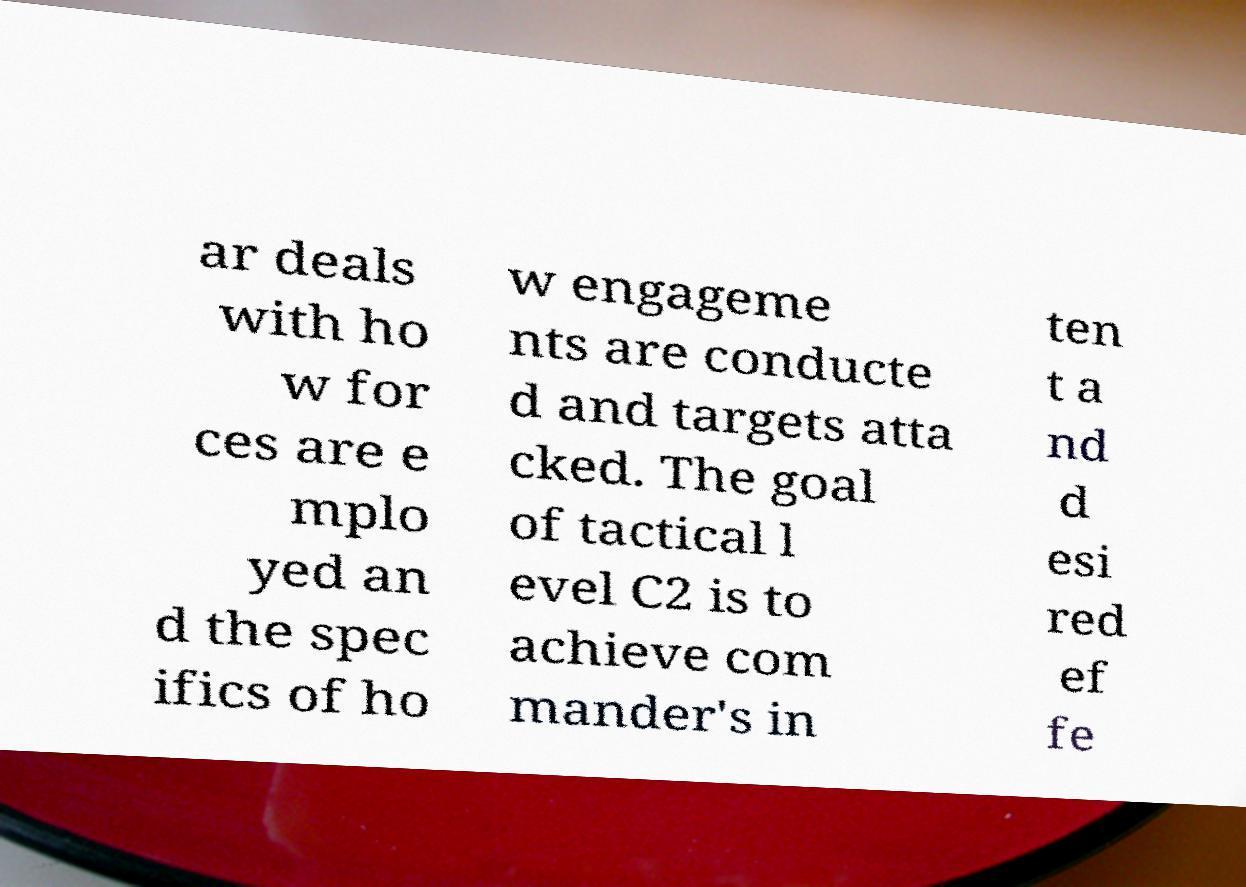For documentation purposes, I need the text within this image transcribed. Could you provide that? ar deals with ho w for ces are e mplo yed an d the spec ifics of ho w engageme nts are conducte d and targets atta cked. The goal of tactical l evel C2 is to achieve com mander's in ten t a nd d esi red ef fe 